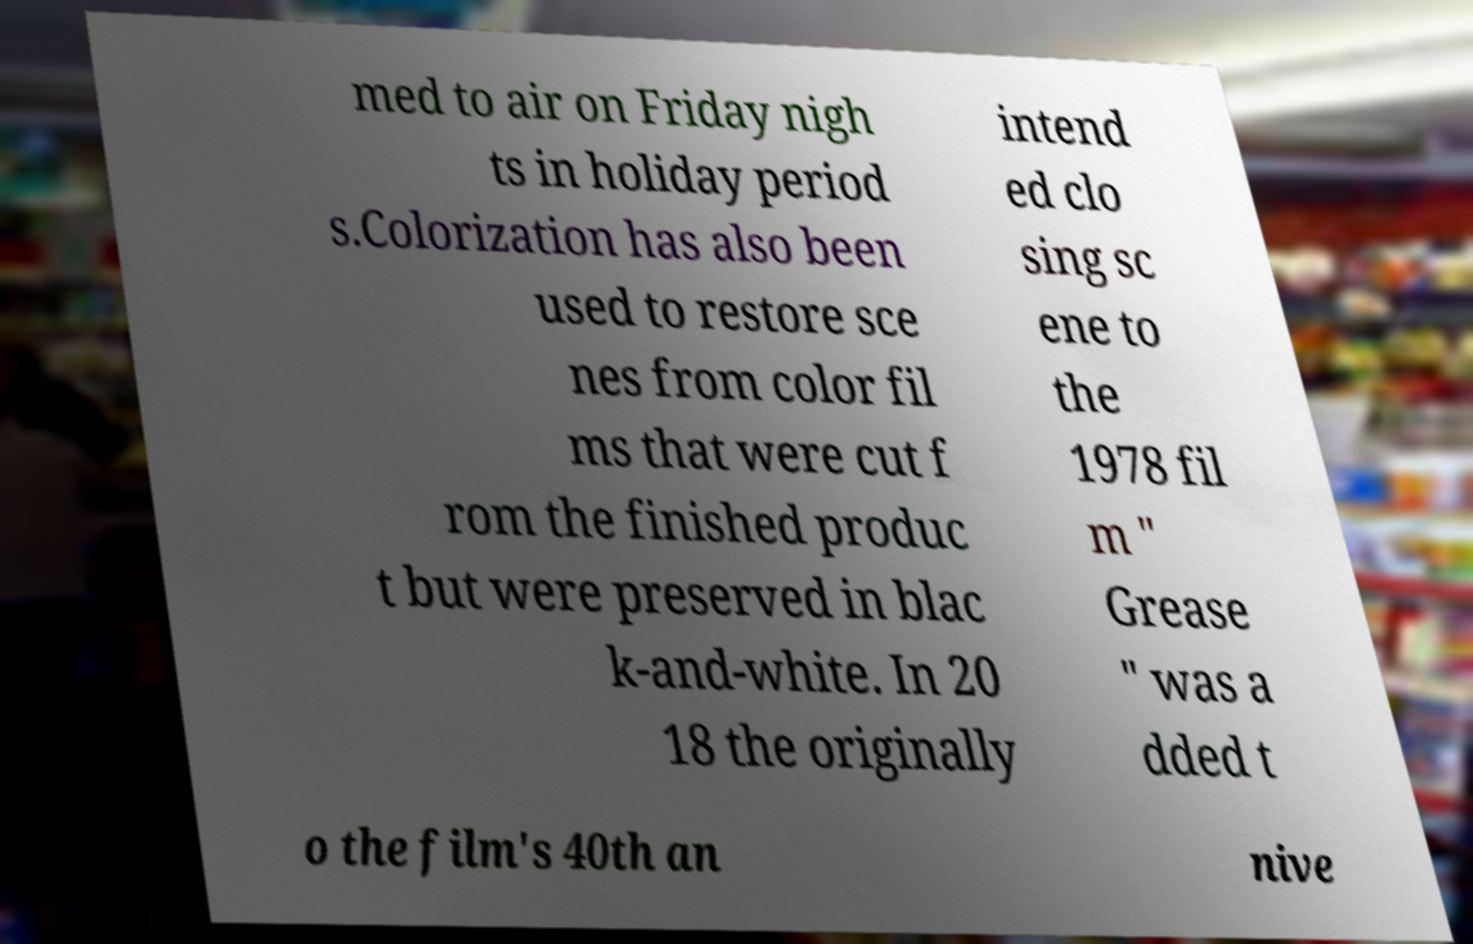There's text embedded in this image that I need extracted. Can you transcribe it verbatim? med to air on Friday nigh ts in holiday period s.Colorization has also been used to restore sce nes from color fil ms that were cut f rom the finished produc t but were preserved in blac k-and-white. In 20 18 the originally intend ed clo sing sc ene to the 1978 fil m " Grease " was a dded t o the film's 40th an nive 